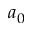Convert formula to latex. <formula><loc_0><loc_0><loc_500><loc_500>a _ { 0 }</formula> 